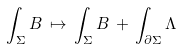<formula> <loc_0><loc_0><loc_500><loc_500>\int _ { \Sigma } B \, \mapsto \, \int _ { \Sigma } B \, + \, \int _ { \partial \Sigma } \Lambda</formula> 